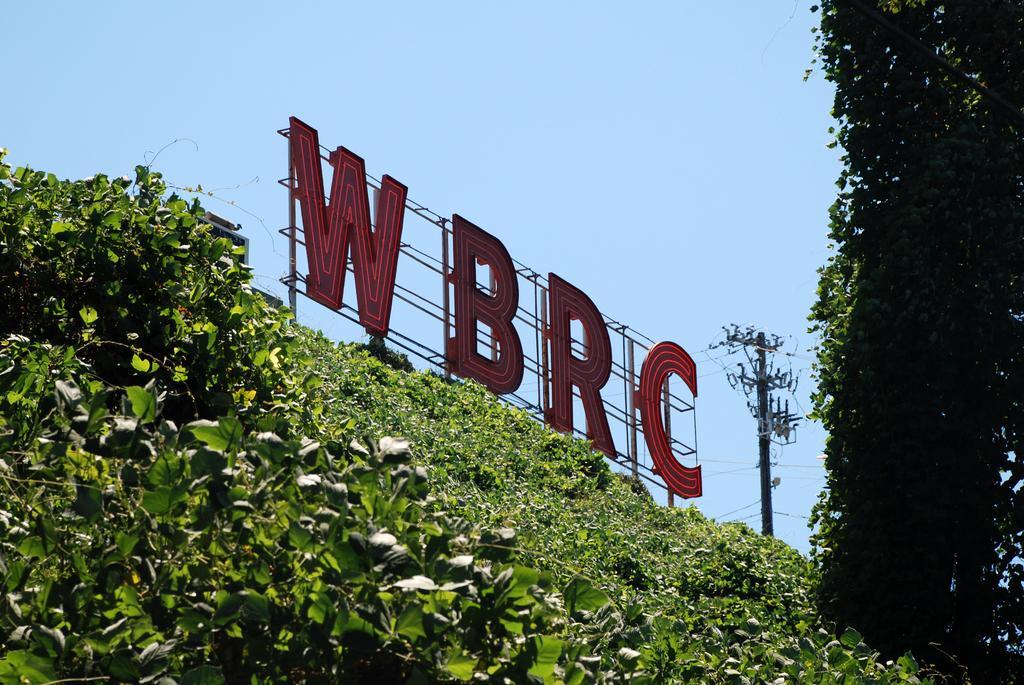In one or two sentences, can you explain what this image depicts? In the middle of this image, there is a hoarding. Beside this hoarding, there are plants having green color leaves. On the right side, there are trees and there is a pole which is having electric lines. In the background, there is blue sky. 